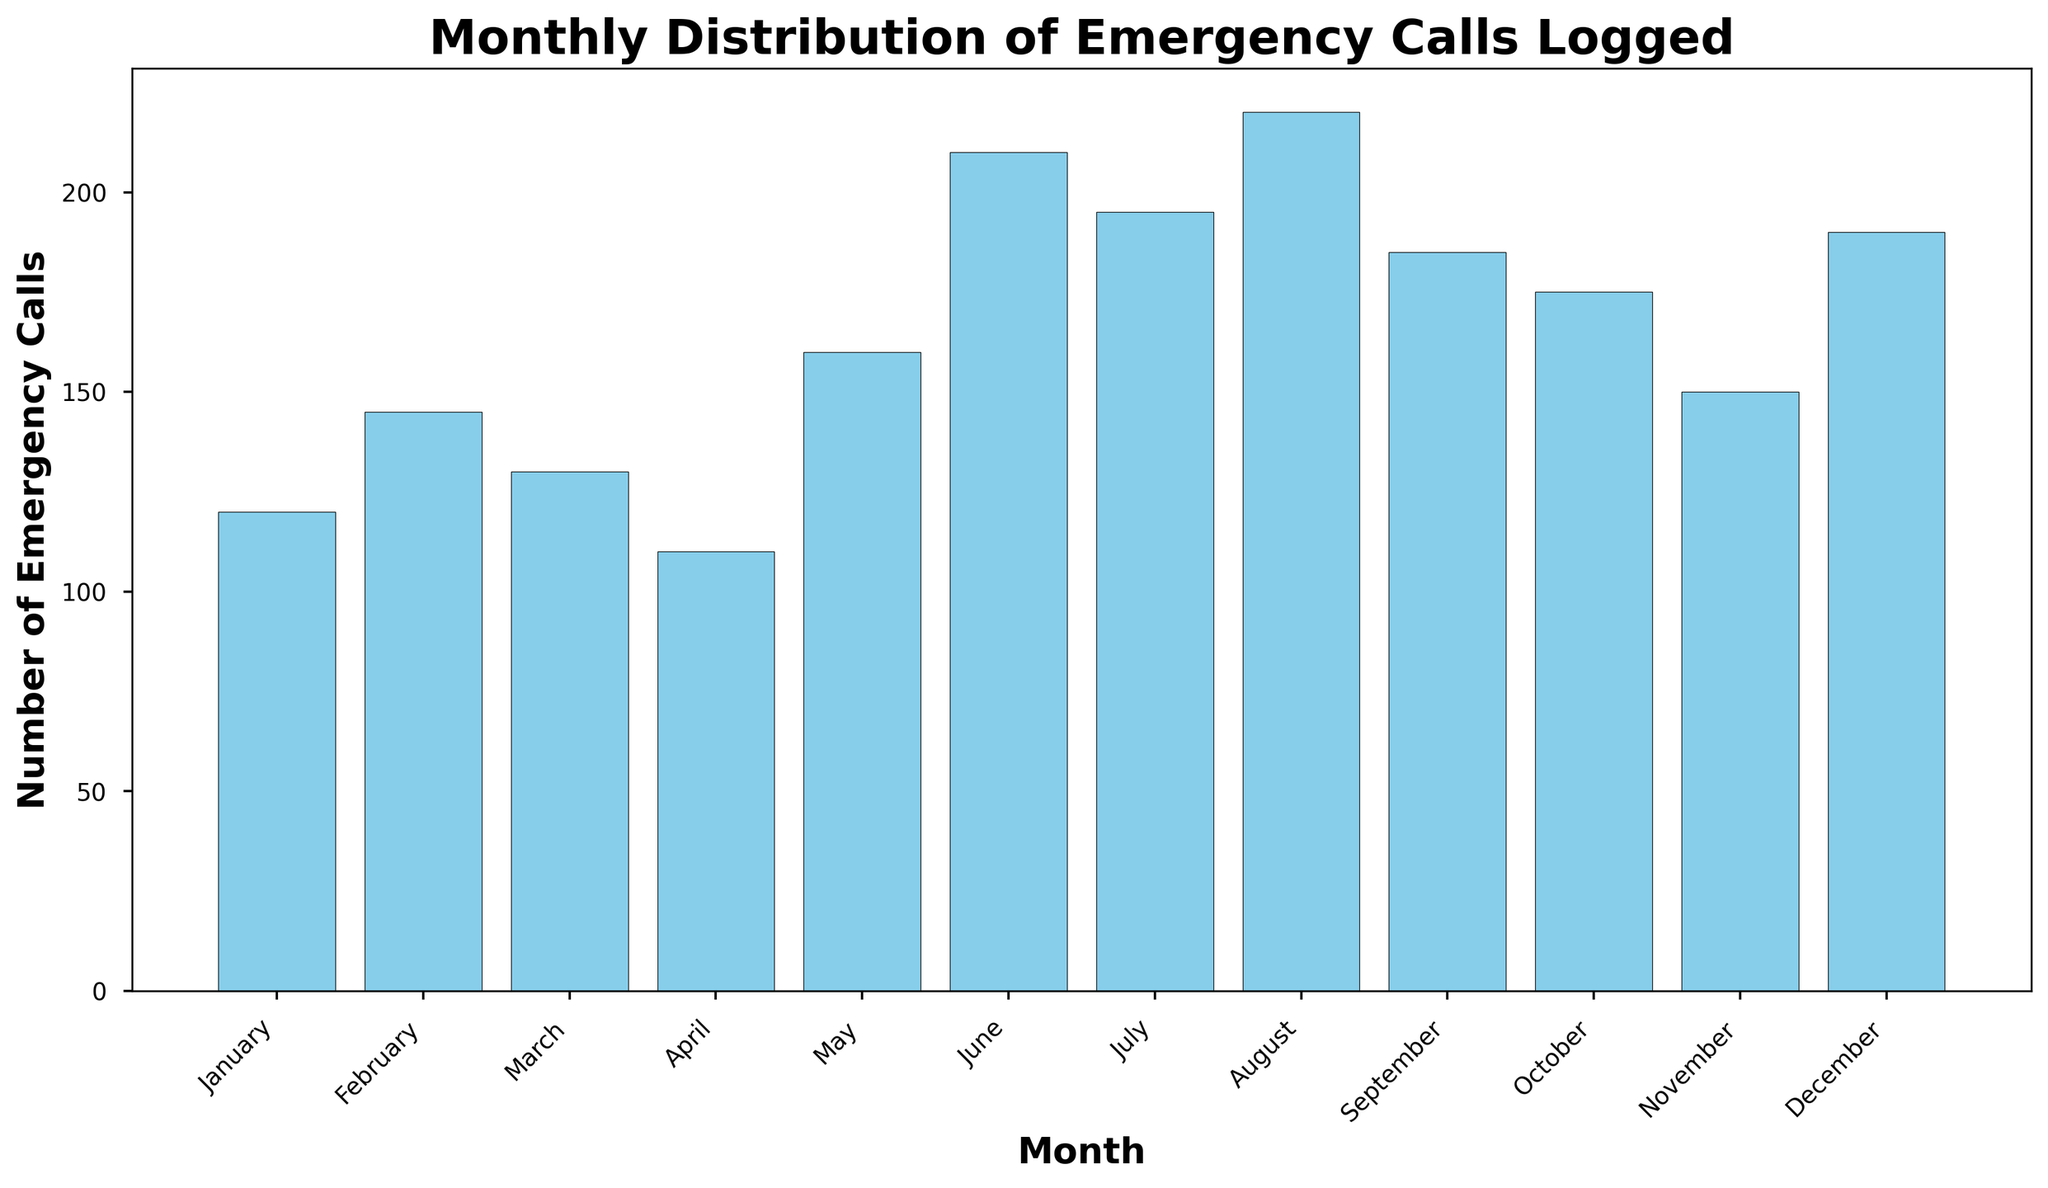Which month had the highest number of emergency calls? Look at the heights of the bars in the histogram and identify the tallest bar. The month corresponding to the tallest bar has the highest number of calls. August has the tallest bar with 220 calls.
Answer: August Which month had the lowest number of emergency calls? Look at the heights of the bars in the histogram and identify the shortest bar. The month corresponding to the shortest bar has the lowest number of calls. April has the shortest bar with 110 calls.
Answer: April How many more emergency calls were logged in July compared to April? Identify the heights of the bars for July and April. July has 195 calls, and April has 110 calls. Subtract April's calls from July's calls: 195 - 110.
Answer: 85 What is the total number of emergency calls logged in the last three months of the year? Sum the heights of the bars for October, November, and December. October has 175 calls, November has 150 calls, and December has 190 calls. The total is 175 + 150 + 190.
Answer: 515 Which month had more emergency calls, June or September? Compare the heights of the bars for June and September. June has 210 calls, and September has 185 calls. Since 210 is greater than 185, June had more calls.
Answer: June What is the average number of emergency calls per month over the year? Sum the heights of all the bars and divide by 12 (the number of months). The total number of calls is 120 + 145 + 130 + 110 + 160 + 210 + 195 + 220 + 185 + 175 + 150 + 190 = 1990. The average is 1990 / 12.
Answer: 165.83 Which quarter of the year had the most emergency calls? Divide the months into quarters: Q1 (Jan-Mar), Q2 (Apr-Jun), Q3 (Jul-Sep), Q4 (Oct-Dec). Sum the calls for each quarter: Q1 = 120 + 145 + 130 = 395, Q2 = 110 + 160 + 210 = 480, Q3 = 195 + 220 + 185 = 600, Q4 = 175 + 150 + 190 = 515. The quarter with the highest sum is Q3.
Answer: Q3 What is the difference in emergency calls between the month with the highest and the month with the lowest calls? Identify the highest and lowest numbers of calls. August has 220 calls, and April has 110 calls. Subtract the lowest from the highest: 220 - 110.
Answer: 110 